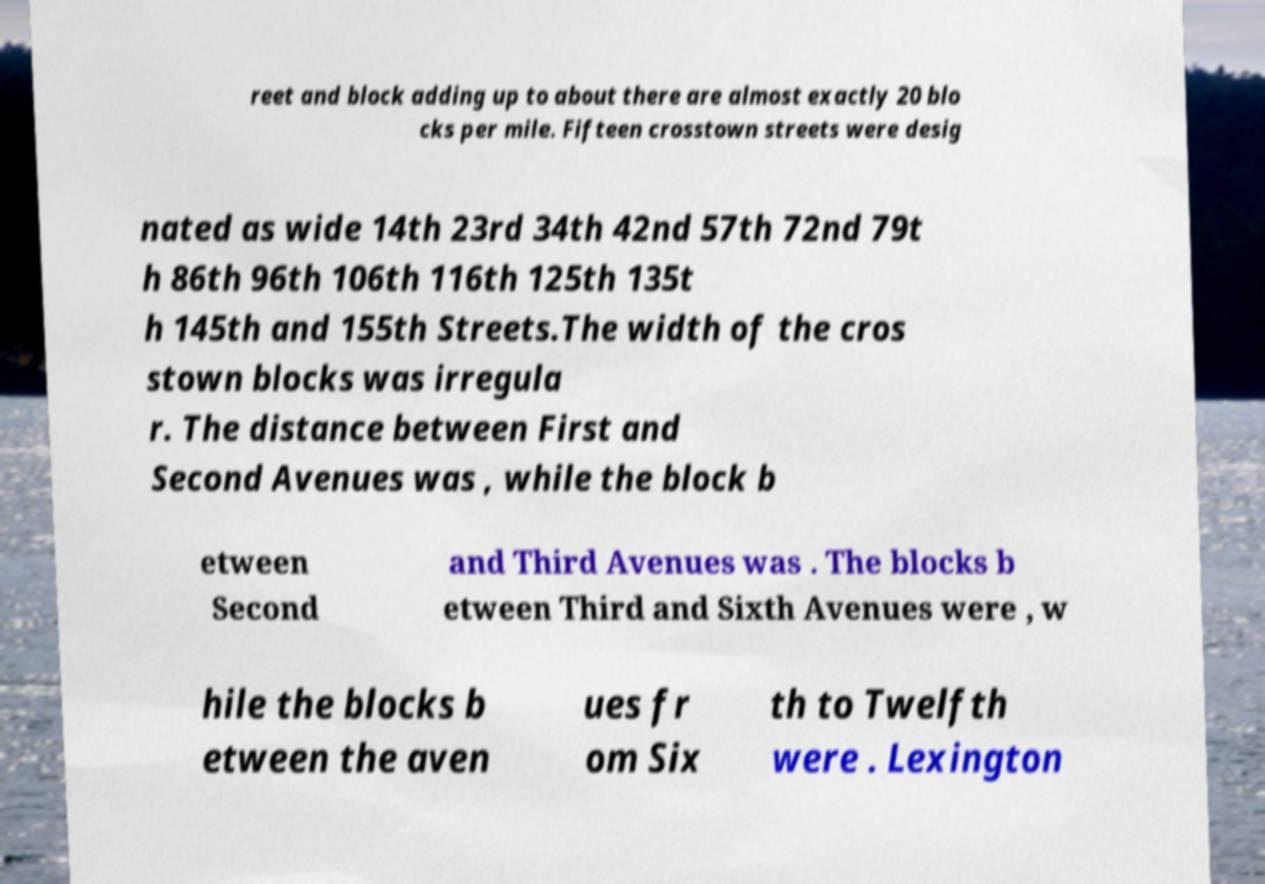There's text embedded in this image that I need extracted. Can you transcribe it verbatim? reet and block adding up to about there are almost exactly 20 blo cks per mile. Fifteen crosstown streets were desig nated as wide 14th 23rd 34th 42nd 57th 72nd 79t h 86th 96th 106th 116th 125th 135t h 145th and 155th Streets.The width of the cros stown blocks was irregula r. The distance between First and Second Avenues was , while the block b etween Second and Third Avenues was . The blocks b etween Third and Sixth Avenues were , w hile the blocks b etween the aven ues fr om Six th to Twelfth were . Lexington 